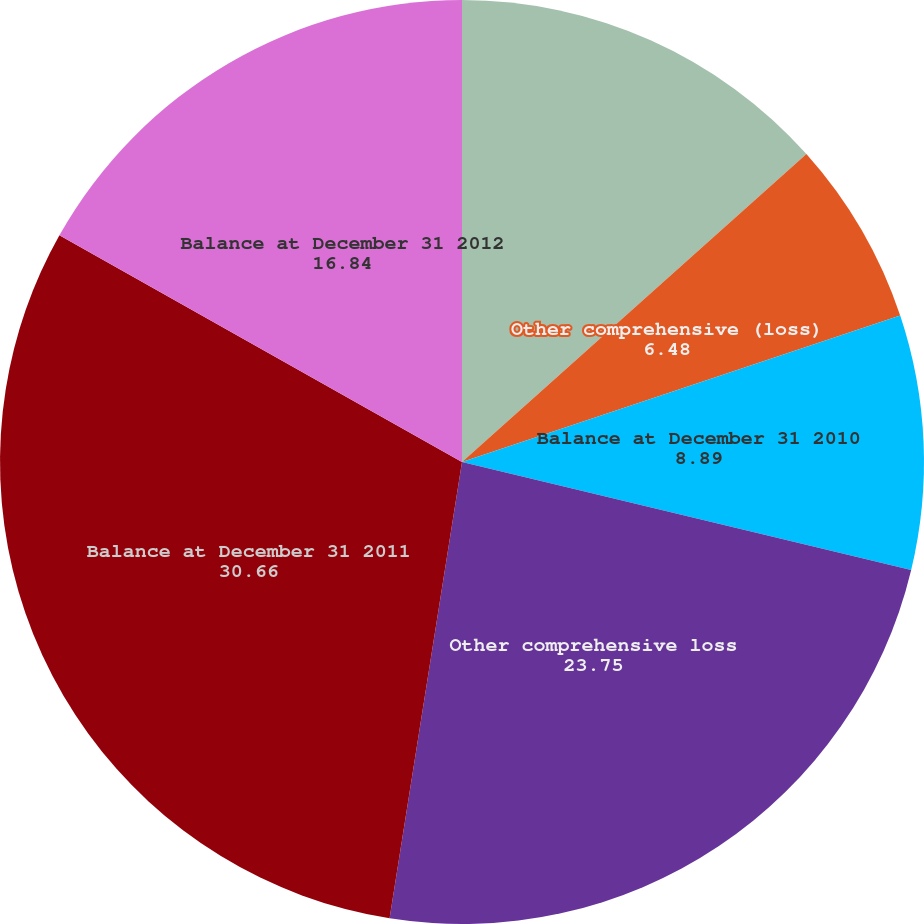Convert chart. <chart><loc_0><loc_0><loc_500><loc_500><pie_chart><fcel>Balance at January 1 2010<fcel>Other comprehensive (loss)<fcel>Balance at December 31 2010<fcel>Other comprehensive loss<fcel>Balance at December 31 2011<fcel>Balance at December 31 2012<nl><fcel>13.39%<fcel>6.48%<fcel>8.89%<fcel>23.75%<fcel>30.66%<fcel>16.84%<nl></chart> 